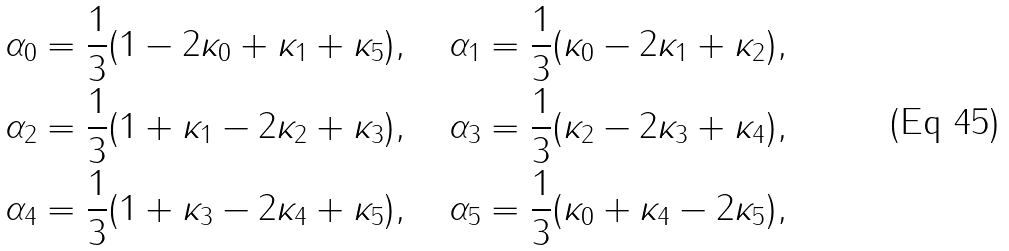<formula> <loc_0><loc_0><loc_500><loc_500>& \alpha _ { 0 } = \frac { 1 } { 3 } ( 1 - 2 \kappa _ { 0 } + \kappa _ { 1 } + \kappa _ { 5 } ) , \quad \alpha _ { 1 } = \frac { 1 } { 3 } ( \kappa _ { 0 } - 2 \kappa _ { 1 } + \kappa _ { 2 } ) , \\ & \alpha _ { 2 } = \frac { 1 } { 3 } ( 1 + \kappa _ { 1 } - 2 \kappa _ { 2 } + \kappa _ { 3 } ) , \quad \alpha _ { 3 } = \frac { 1 } { 3 } ( \kappa _ { 2 } - 2 \kappa _ { 3 } + \kappa _ { 4 } ) , \\ & \alpha _ { 4 } = \frac { 1 } { 3 } ( 1 + \kappa _ { 3 } - 2 \kappa _ { 4 } + \kappa _ { 5 } ) , \quad \alpha _ { 5 } = \frac { 1 } { 3 } ( \kappa _ { 0 } + \kappa _ { 4 } - 2 \kappa _ { 5 } ) ,</formula> 